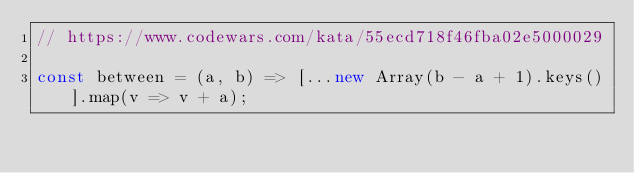Convert code to text. <code><loc_0><loc_0><loc_500><loc_500><_JavaScript_>// https://www.codewars.com/kata/55ecd718f46fba02e5000029

const between = (a, b) => [...new Array(b - a + 1).keys()].map(v => v + a);

</code> 